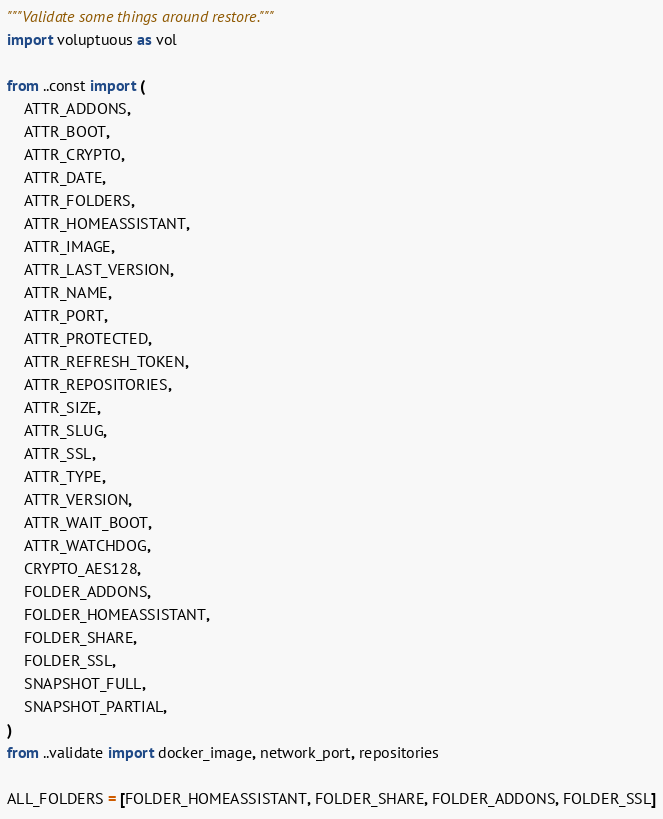<code> <loc_0><loc_0><loc_500><loc_500><_Python_>"""Validate some things around restore."""
import voluptuous as vol

from ..const import (
    ATTR_ADDONS,
    ATTR_BOOT,
    ATTR_CRYPTO,
    ATTR_DATE,
    ATTR_FOLDERS,
    ATTR_HOMEASSISTANT,
    ATTR_IMAGE,
    ATTR_LAST_VERSION,
    ATTR_NAME,
    ATTR_PORT,
    ATTR_PROTECTED,
    ATTR_REFRESH_TOKEN,
    ATTR_REPOSITORIES,
    ATTR_SIZE,
    ATTR_SLUG,
    ATTR_SSL,
    ATTR_TYPE,
    ATTR_VERSION,
    ATTR_WAIT_BOOT,
    ATTR_WATCHDOG,
    CRYPTO_AES128,
    FOLDER_ADDONS,
    FOLDER_HOMEASSISTANT,
    FOLDER_SHARE,
    FOLDER_SSL,
    SNAPSHOT_FULL,
    SNAPSHOT_PARTIAL,
)
from ..validate import docker_image, network_port, repositories

ALL_FOLDERS = [FOLDER_HOMEASSISTANT, FOLDER_SHARE, FOLDER_ADDONS, FOLDER_SSL]

</code> 